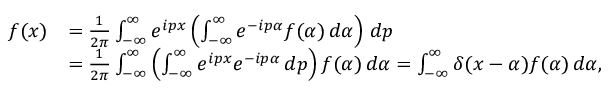Convert formula to latex. <formula><loc_0><loc_0><loc_500><loc_500>{ \begin{array} { r l } { f ( x ) } & { = { \frac { 1 } { 2 \pi } } \int _ { - \infty } ^ { \infty } e ^ { i p x } \left ( \int _ { - \infty } ^ { \infty } e ^ { - i p \alpha } f ( \alpha ) \, d \alpha \right ) \, d p } \\ & { = { \frac { 1 } { 2 \pi } } \int _ { - \infty } ^ { \infty } \left ( \int _ { - \infty } ^ { \infty } e ^ { i p x } e ^ { - i p \alpha } \, d p \right ) f ( \alpha ) \, d \alpha = \int _ { - \infty } ^ { \infty } \delta ( x - \alpha ) f ( \alpha ) \, d \alpha , } \end{array} }</formula> 